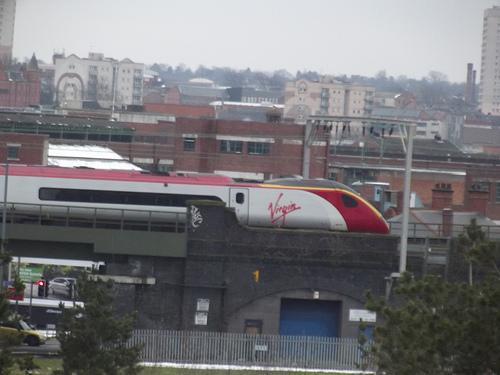How many trains are there?
Give a very brief answer. 1. 